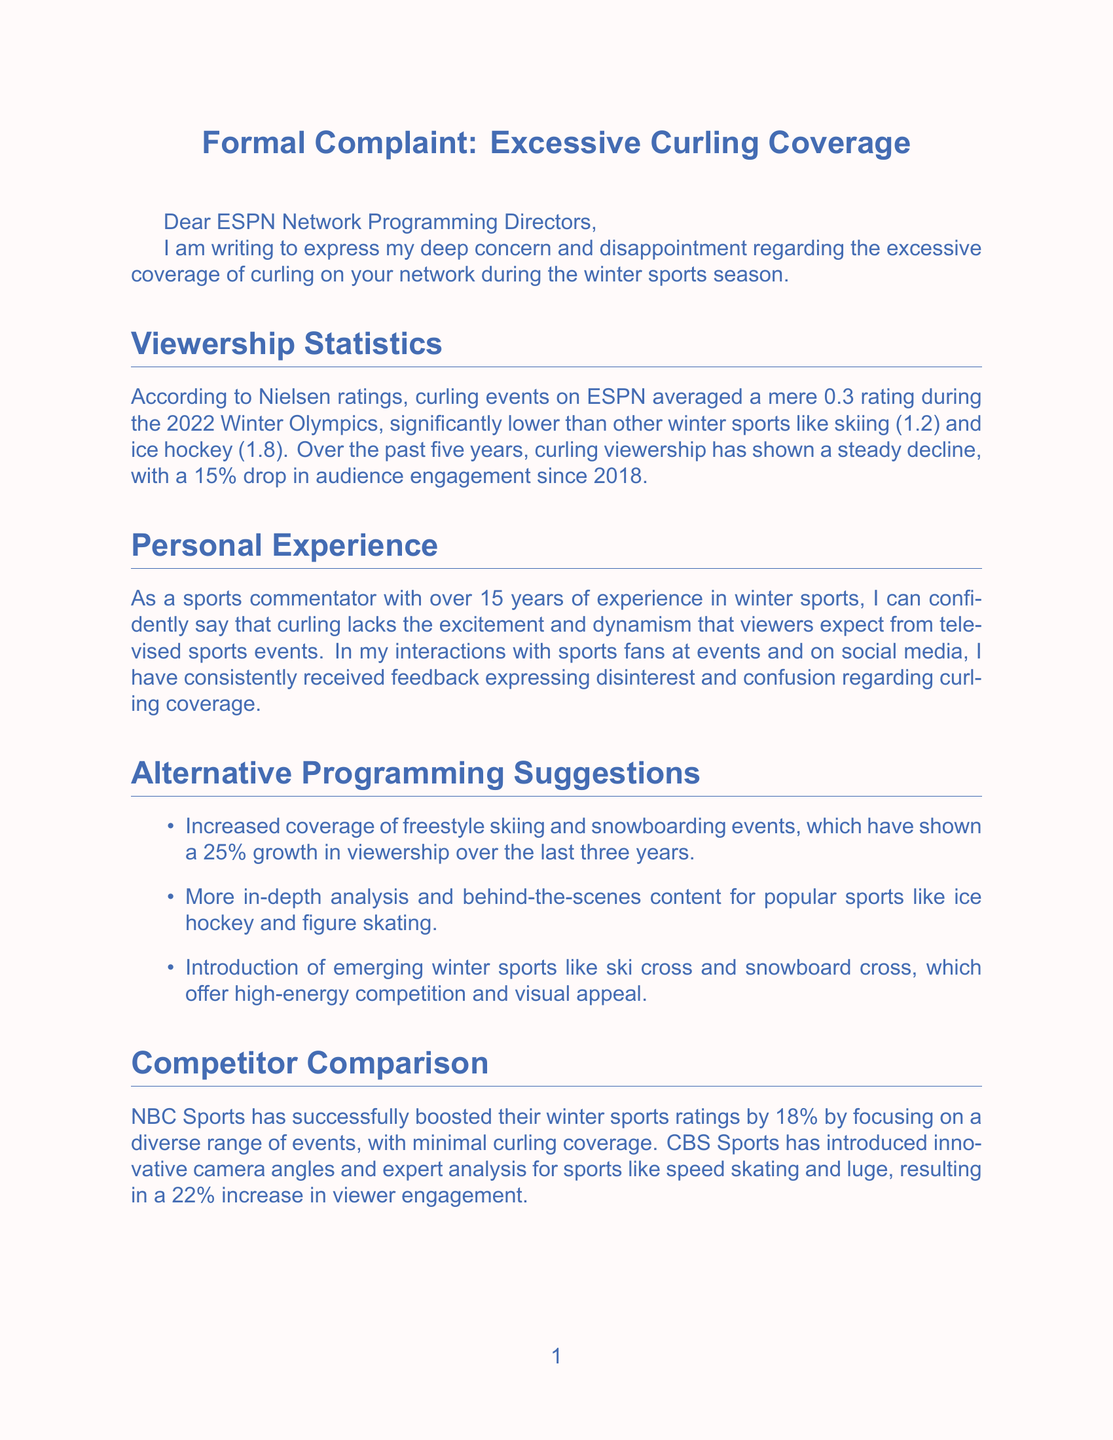What is the average rating of curling events during the 2022 Winter Olympics? The document states that curling events on ESPN averaged a mere 0.3 rating during the 2022 Winter Olympics.
Answer: 0.3 What percentage drop in audience engagement has curling viewership shown since 2018? The body of the letter mentions a 15% drop in audience engagement since 2018.
Answer: 15% Which winter sports rated higher than curling during the Olympics? The document indicates that skiing and ice hockey had ratings of 1.2 and 1.8, respectively, which are higher than curling's rating.
Answer: skiing and ice hockey What alternative programming suggestion had the highest viewership growth? The letter suggests increased coverage of freestyle skiing and snowboarding events, which have shown a 25% growth in viewership over the last three years.
Answer: freestyle skiing and snowboarding What percentage of ESPN subscribers prefer reduced curling coverage? According to the survey results mentioned, 78% of ESPN subscribers expressed a preference for reduced curling coverage.
Answer: 78% Which sports network is mentioned as having increased their winter sports ratings by focusing on diverse events? The document refers to NBC Sports as having successfully boosted their winter sports ratings by focusing on a diverse range of events.
Answer: NBC Sports What is the commentator's experience in winter sports? The letter states that the commentator has over 15 years of experience in winter sports.
Answer: 15 years How many likes, shares, and comments do curling-related posts receive compared to other content? The analysis shows that curling-related posts receive 70% fewer likes, shares, and comments compared to other winter sports content on ESPN's platforms.
Answer: 70% fewer 